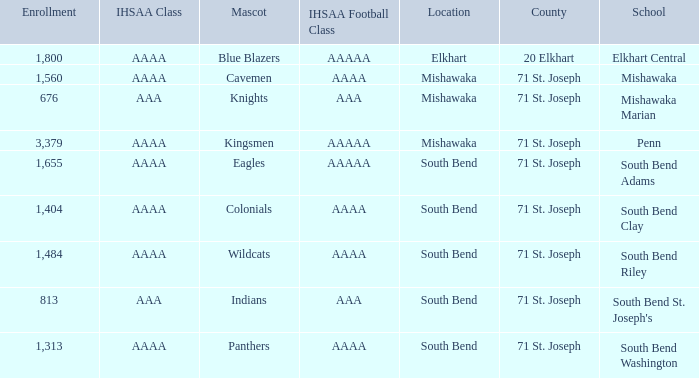What school has south bend as the location, with indians as the mascot? South Bend St. Joseph's. 